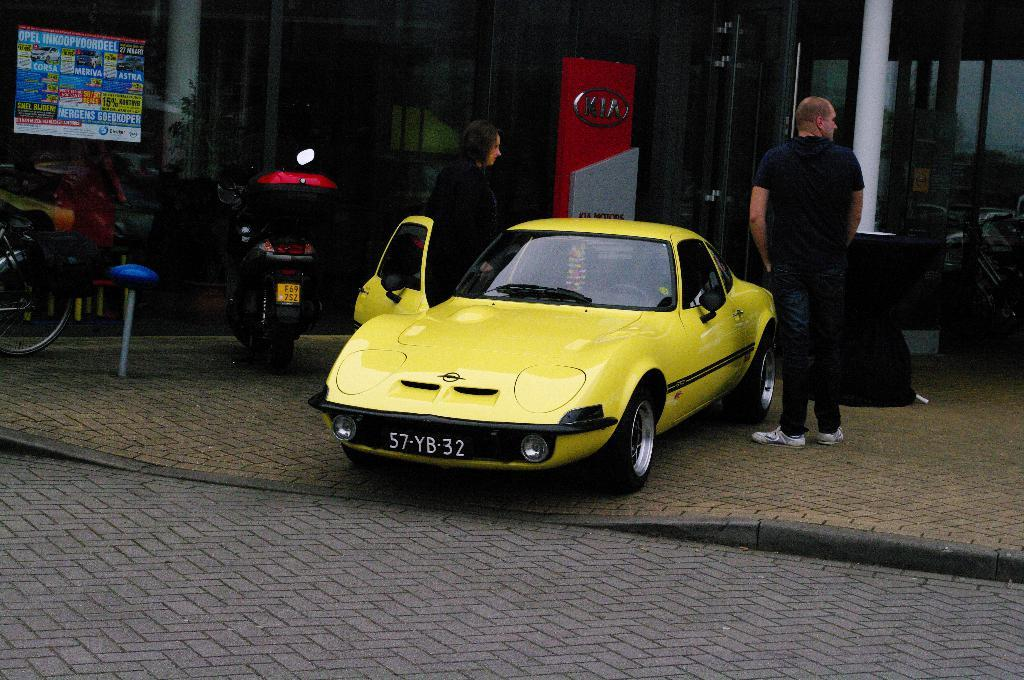<image>
Summarize the visual content of the image. A man and a woman are next to a yellow car that says 57-YB-32 on it. 